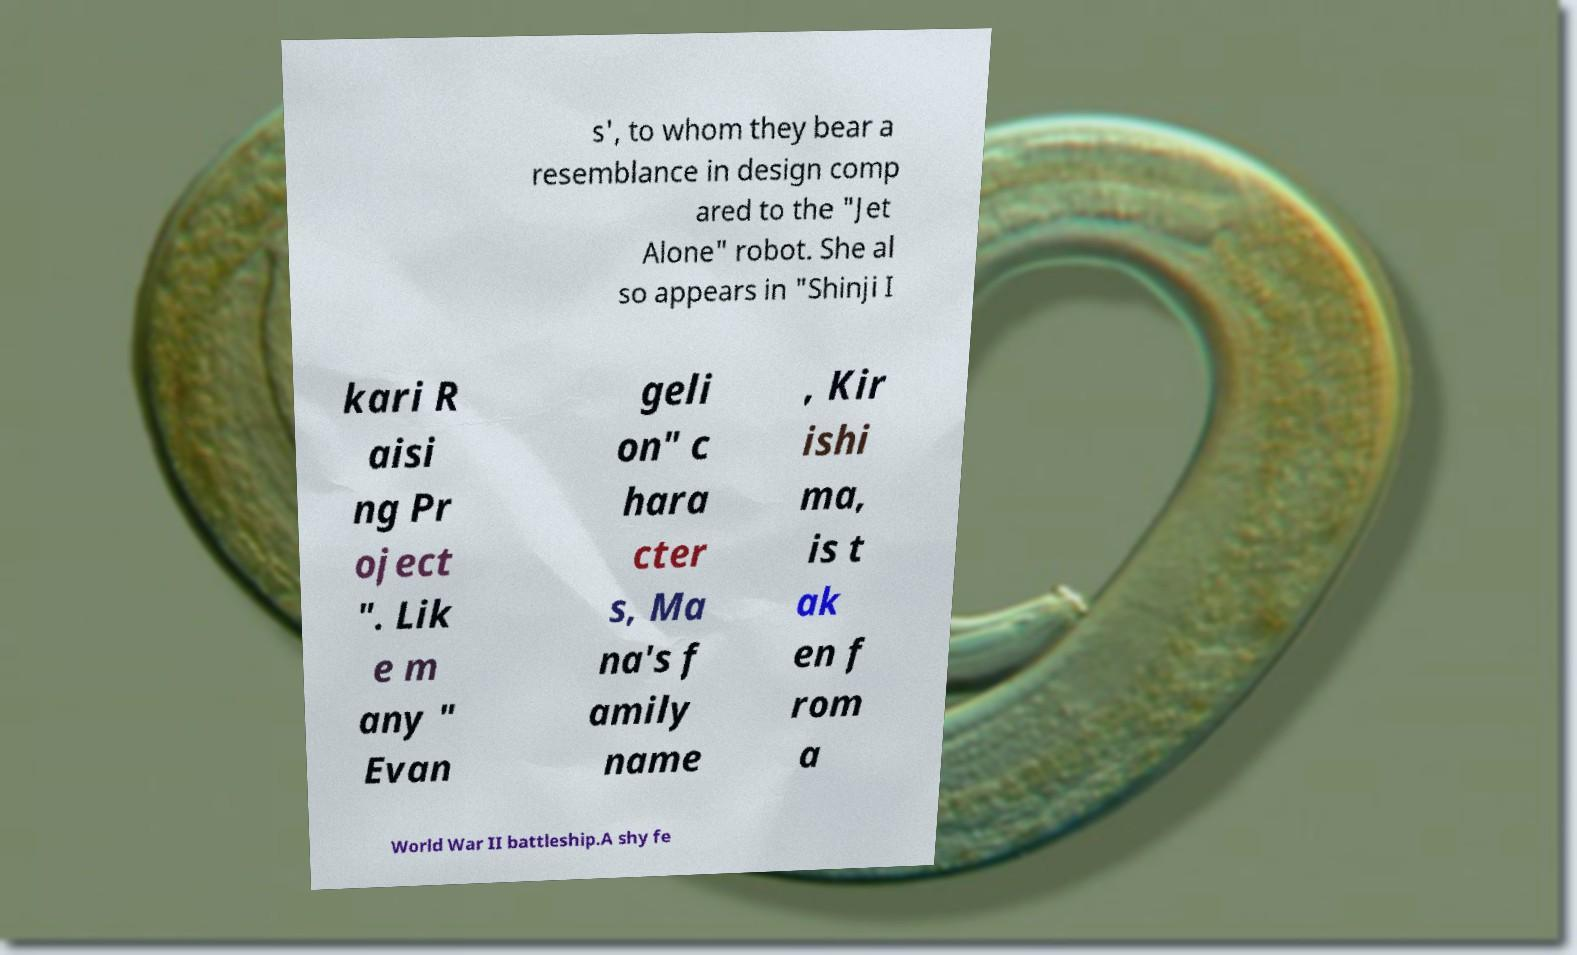Can you accurately transcribe the text from the provided image for me? s', to whom they bear a resemblance in design comp ared to the "Jet Alone" robot. She al so appears in "Shinji I kari R aisi ng Pr oject ". Lik e m any " Evan geli on" c hara cter s, Ma na's f amily name , Kir ishi ma, is t ak en f rom a World War II battleship.A shy fe 